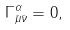<formula> <loc_0><loc_0><loc_500><loc_500>\Gamma ^ { \alpha } _ { \bar { \mu } \bar { \nu } } = 0 ,</formula> 